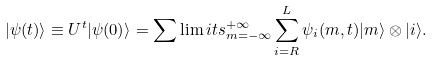<formula> <loc_0><loc_0><loc_500><loc_500>| \psi ( t ) \rangle \equiv U ^ { t } | \psi ( 0 ) \rangle = \sum \lim i t s _ { m = - \infty } ^ { + \infty } \sum _ { i = R } ^ { L } \psi _ { i } ( m , t ) | m \rangle \otimes | i \rangle .</formula> 